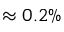Convert formula to latex. <formula><loc_0><loc_0><loc_500><loc_500>\approx 0 . 2 \%</formula> 